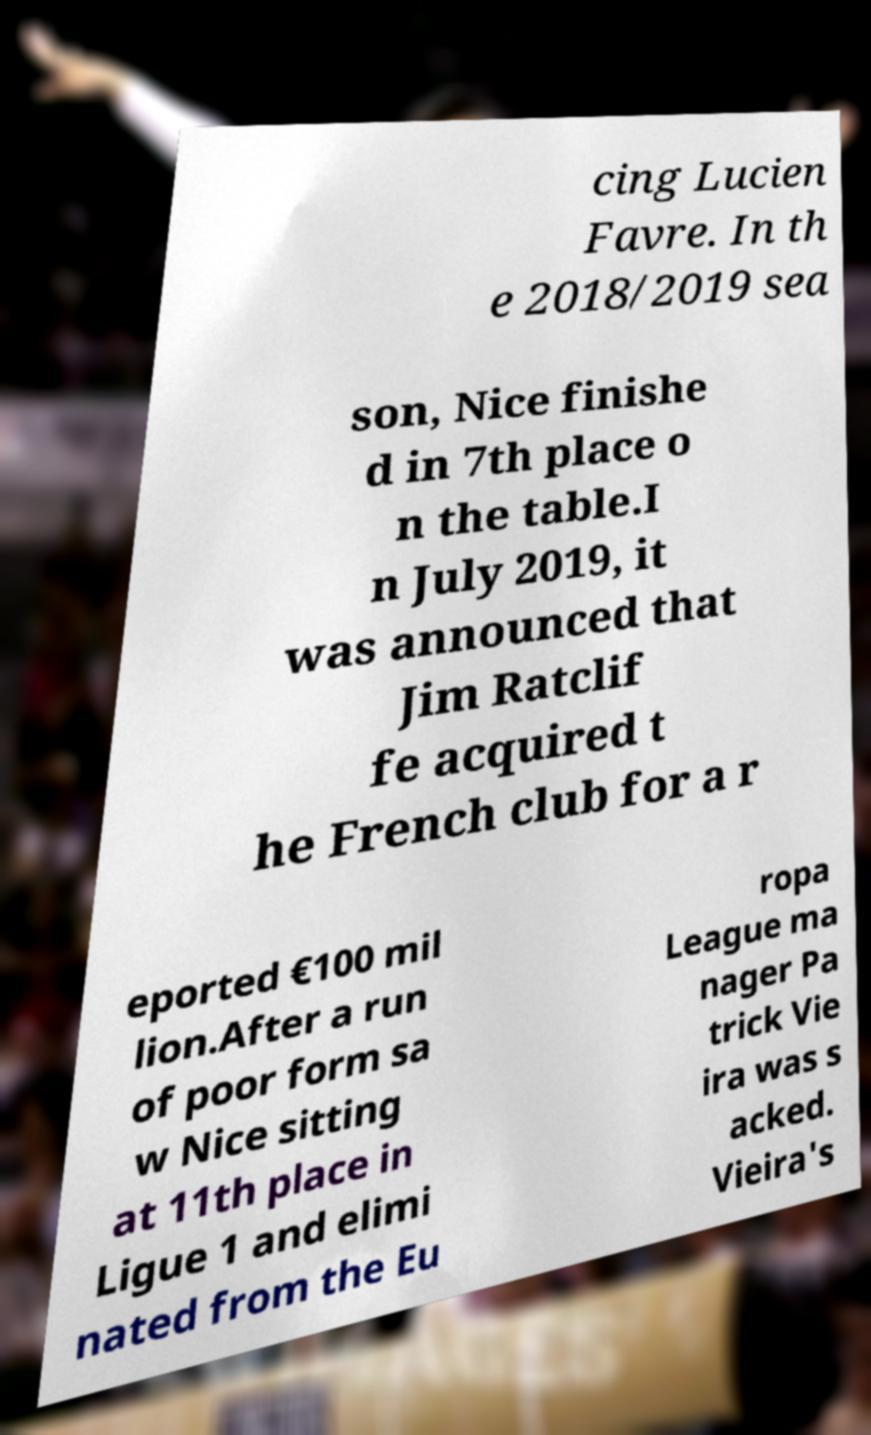I need the written content from this picture converted into text. Can you do that? cing Lucien Favre. In th e 2018/2019 sea son, Nice finishe d in 7th place o n the table.I n July 2019, it was announced that Jim Ratclif fe acquired t he French club for a r eported €100 mil lion.After a run of poor form sa w Nice sitting at 11th place in Ligue 1 and elimi nated from the Eu ropa League ma nager Pa trick Vie ira was s acked. Vieira's 